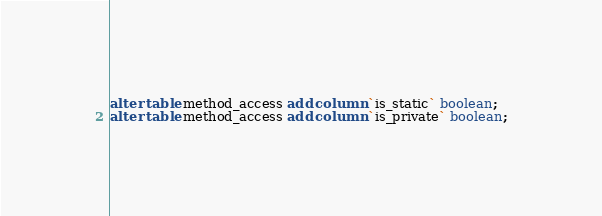<code> <loc_0><loc_0><loc_500><loc_500><_SQL_>alter table method_access add column `is_static` boolean;
alter table method_access add column `is_private` boolean;</code> 